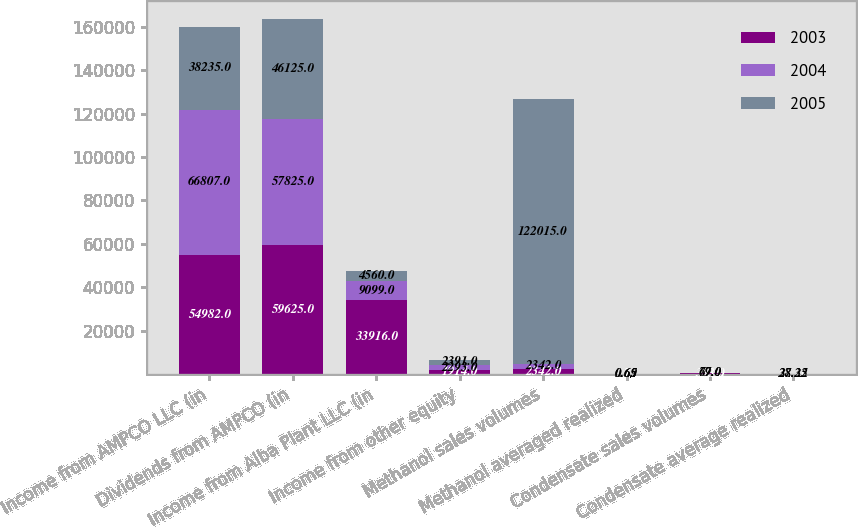<chart> <loc_0><loc_0><loc_500><loc_500><stacked_bar_chart><ecel><fcel>Income from AMPCO LLC (in<fcel>Dividends from AMPCO (in<fcel>Income from Alba Plant LLC (in<fcel>Income from other equity<fcel>Methanol sales volumes<fcel>Methanol averaged realized<fcel>Condensate sales volumes<fcel>Condensate average realized<nl><fcel>2003<fcel>54982<fcel>59625<fcel>33916<fcel>1914<fcel>2342<fcel>0.77<fcel>333<fcel>55.76<nl><fcel>2004<fcel>66807<fcel>57825<fcel>9099<fcel>2293<fcel>2342<fcel>0.69<fcel>69<fcel>37.25<nl><fcel>2005<fcel>38235<fcel>46125<fcel>4560<fcel>2391<fcel>122015<fcel>0.65<fcel>77<fcel>28.32<nl></chart> 